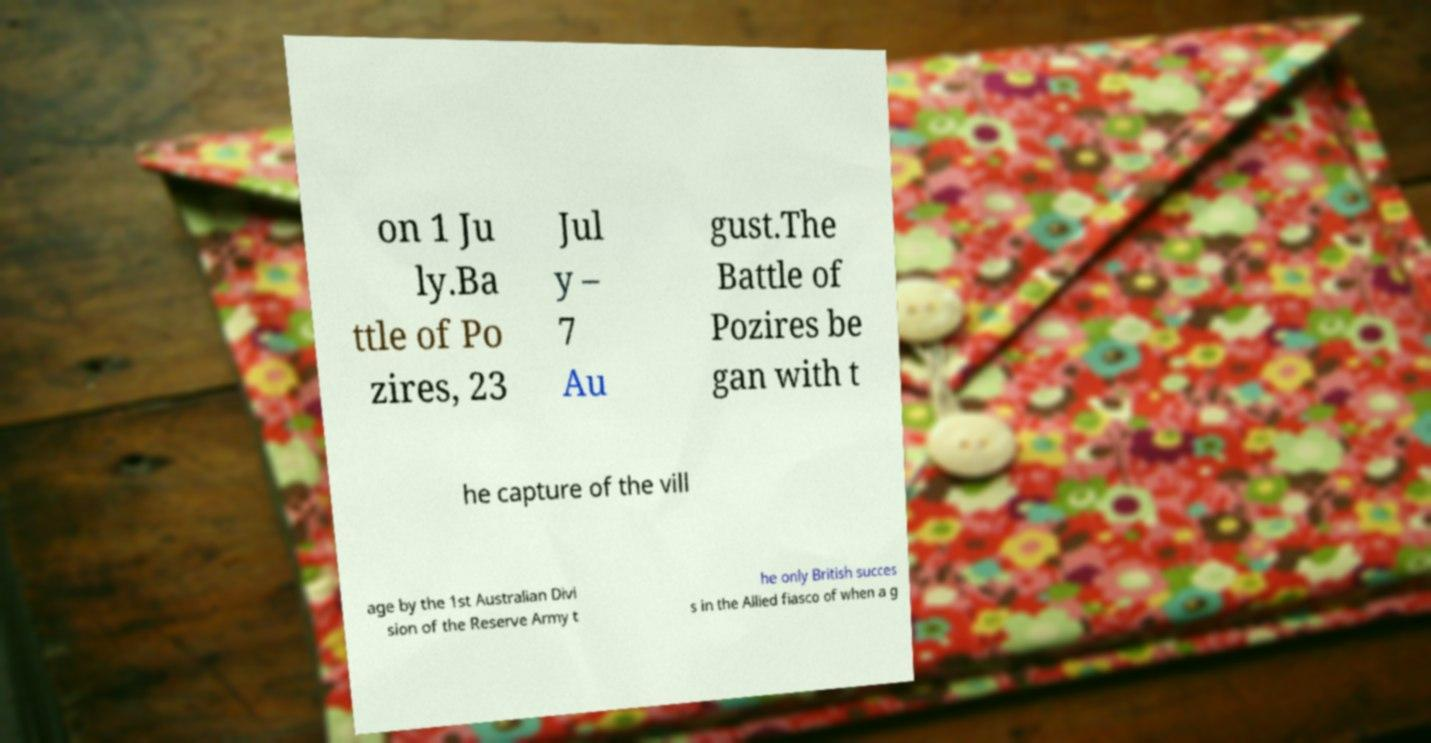What messages or text are displayed in this image? I need them in a readable, typed format. on 1 Ju ly.Ba ttle of Po zires, 23 Jul y – 7 Au gust.The Battle of Pozires be gan with t he capture of the vill age by the 1st Australian Divi sion of the Reserve Army t he only British succes s in the Allied fiasco of when a g 